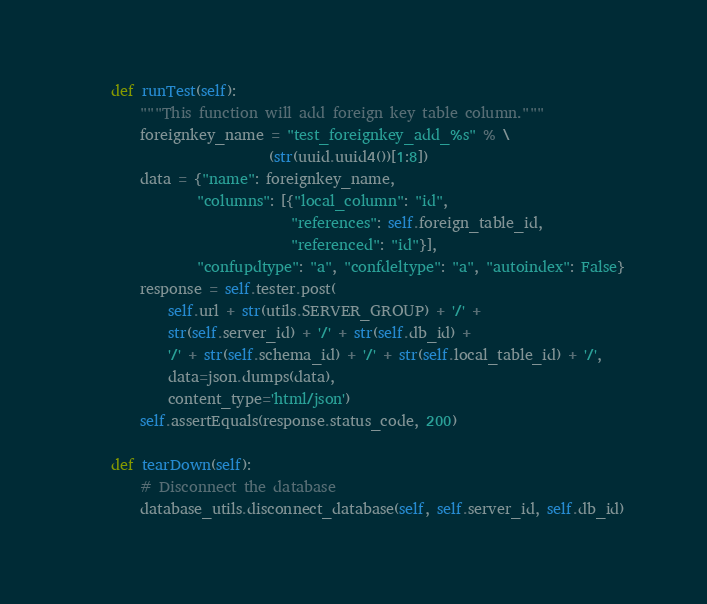Convert code to text. <code><loc_0><loc_0><loc_500><loc_500><_Python_>
    def runTest(self):
        """This function will add foreign key table column."""
        foreignkey_name = "test_foreignkey_add_%s" % \
                          (str(uuid.uuid4())[1:8])
        data = {"name": foreignkey_name,
                "columns": [{"local_column": "id",
                             "references": self.foreign_table_id,
                             "referenced": "id"}],
                "confupdtype": "a", "confdeltype": "a", "autoindex": False}
        response = self.tester.post(
            self.url + str(utils.SERVER_GROUP) + '/' +
            str(self.server_id) + '/' + str(self.db_id) +
            '/' + str(self.schema_id) + '/' + str(self.local_table_id) + '/',
            data=json.dumps(data),
            content_type='html/json')
        self.assertEquals(response.status_code, 200)

    def tearDown(self):
        # Disconnect the database
        database_utils.disconnect_database(self, self.server_id, self.db_id)
</code> 